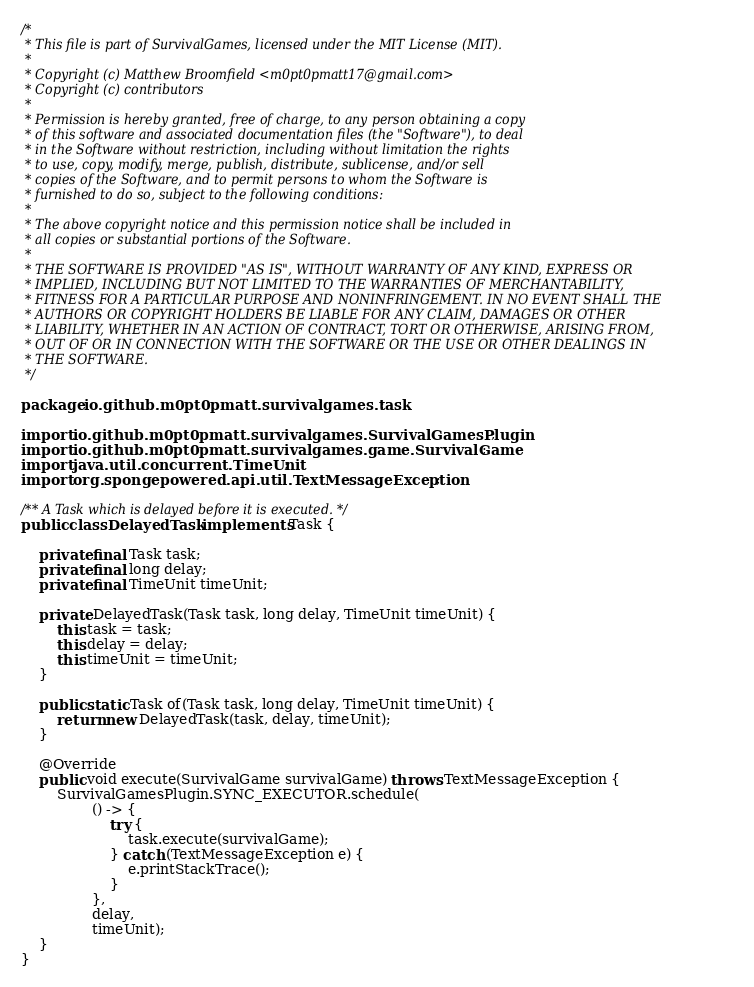Convert code to text. <code><loc_0><loc_0><loc_500><loc_500><_Java_>/*
 * This file is part of SurvivalGames, licensed under the MIT License (MIT).
 *
 * Copyright (c) Matthew Broomfield <m0pt0pmatt17@gmail.com>
 * Copyright (c) contributors
 *
 * Permission is hereby granted, free of charge, to any person obtaining a copy
 * of this software and associated documentation files (the "Software"), to deal
 * in the Software without restriction, including without limitation the rights
 * to use, copy, modify, merge, publish, distribute, sublicense, and/or sell
 * copies of the Software, and to permit persons to whom the Software is
 * furnished to do so, subject to the following conditions:
 *
 * The above copyright notice and this permission notice shall be included in
 * all copies or substantial portions of the Software.
 *
 * THE SOFTWARE IS PROVIDED "AS IS", WITHOUT WARRANTY OF ANY KIND, EXPRESS OR
 * IMPLIED, INCLUDING BUT NOT LIMITED TO THE WARRANTIES OF MERCHANTABILITY,
 * FITNESS FOR A PARTICULAR PURPOSE AND NONINFRINGEMENT. IN NO EVENT SHALL THE
 * AUTHORS OR COPYRIGHT HOLDERS BE LIABLE FOR ANY CLAIM, DAMAGES OR OTHER
 * LIABILITY, WHETHER IN AN ACTION OF CONTRACT, TORT OR OTHERWISE, ARISING FROM,
 * OUT OF OR IN CONNECTION WITH THE SOFTWARE OR THE USE OR OTHER DEALINGS IN
 * THE SOFTWARE.
 */

package io.github.m0pt0pmatt.survivalgames.task;

import io.github.m0pt0pmatt.survivalgames.SurvivalGamesPlugin;
import io.github.m0pt0pmatt.survivalgames.game.SurvivalGame;
import java.util.concurrent.TimeUnit;
import org.spongepowered.api.util.TextMessageException;

/** A Task which is delayed before it is executed. */
public class DelayedTask implements Task {

    private final Task task;
    private final long delay;
    private final TimeUnit timeUnit;

    private DelayedTask(Task task, long delay, TimeUnit timeUnit) {
        this.task = task;
        this.delay = delay;
        this.timeUnit = timeUnit;
    }

    public static Task of(Task task, long delay, TimeUnit timeUnit) {
        return new DelayedTask(task, delay, timeUnit);
    }

    @Override
    public void execute(SurvivalGame survivalGame) throws TextMessageException {
        SurvivalGamesPlugin.SYNC_EXECUTOR.schedule(
                () -> {
                    try {
                        task.execute(survivalGame);
                    } catch (TextMessageException e) {
                        e.printStackTrace();
                    }
                },
                delay,
                timeUnit);
    }
}
</code> 